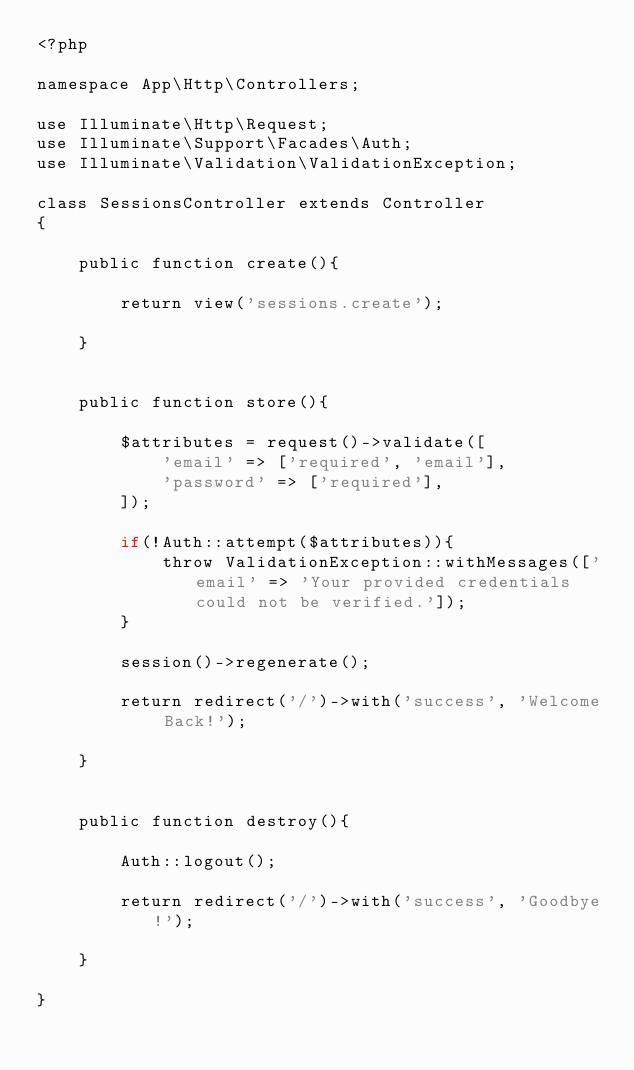Convert code to text. <code><loc_0><loc_0><loc_500><loc_500><_PHP_><?php

namespace App\Http\Controllers;

use Illuminate\Http\Request;
use Illuminate\Support\Facades\Auth;
use Illuminate\Validation\ValidationException;

class SessionsController extends Controller
{

    public function create(){

        return view('sessions.create');

    }


    public function store(){

        $attributes = request()->validate([
            'email' => ['required', 'email'],
            'password' => ['required'],
        ]);

        if(!Auth::attempt($attributes)){
            throw ValidationException::withMessages(['email' => 'Your provided credentials could not be verified.']);
        }

        session()->regenerate();

        return redirect('/')->with('success', 'Welcome Back!');

    }


    public function destroy(){

        Auth::logout();

        return redirect('/')->with('success', 'Goodbye!');

    }

}
</code> 